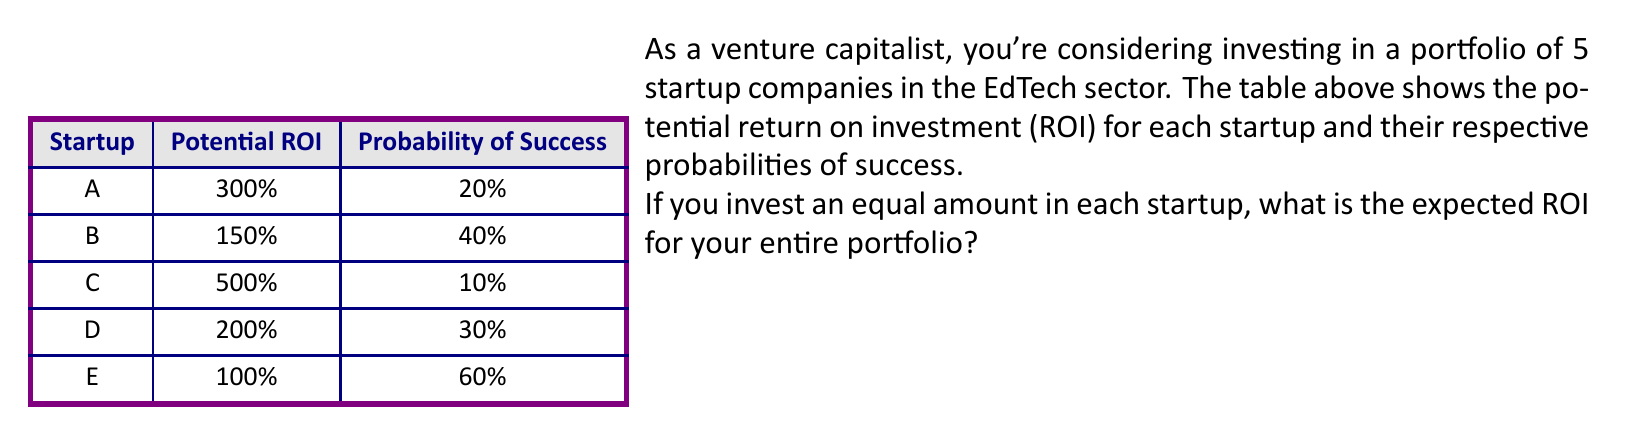Help me with this question. To calculate the expected ROI for the portfolio, we need to follow these steps:

1) First, calculate the expected ROI for each startup:
   Expected ROI = Potential ROI × Probability of Success

   Startup A: $E(ROI_A) = 300\% \times 0.20 = 60\%$
   Startup B: $E(ROI_B) = 150\% \times 0.40 = 60\%$
   Startup C: $E(ROI_C) = 500\% \times 0.10 = 50\%$
   Startup D: $E(ROI_D) = 200\% \times 0.30 = 60\%$
   Startup E: $E(ROI_E) = 100\% \times 0.60 = 60\%$

2) Since we're investing an equal amount in each startup, the portfolio's expected ROI is the average of the individual expected ROIs:

   $$E(ROI_{portfolio}) = \frac{E(ROI_A) + E(ROI_B) + E(ROI_C) + E(ROI_D) + E(ROI_E)}{5}$$

3) Substitute the values:

   $$E(ROI_{portfolio}) = \frac{60\% + 60\% + 50\% + 60\% + 60\%}{5}$$

4) Calculate:

   $$E(ROI_{portfolio}) = \frac{290\%}{5} = 58\%$$

Therefore, the expected ROI for the entire portfolio is 58%.
Answer: 58% 